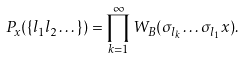<formula> <loc_0><loc_0><loc_500><loc_500>P _ { x } ( \{ l _ { 1 } l _ { 2 } \dots \} ) = \prod _ { k = 1 } ^ { \infty } W _ { B } ( \sigma _ { l _ { k } } \dots \sigma _ { l _ { 1 } } x ) .</formula> 